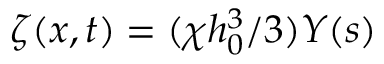<formula> <loc_0><loc_0><loc_500><loc_500>\zeta ( x , t ) = ( \chi h _ { 0 } ^ { 3 } / 3 ) Y ( s )</formula> 